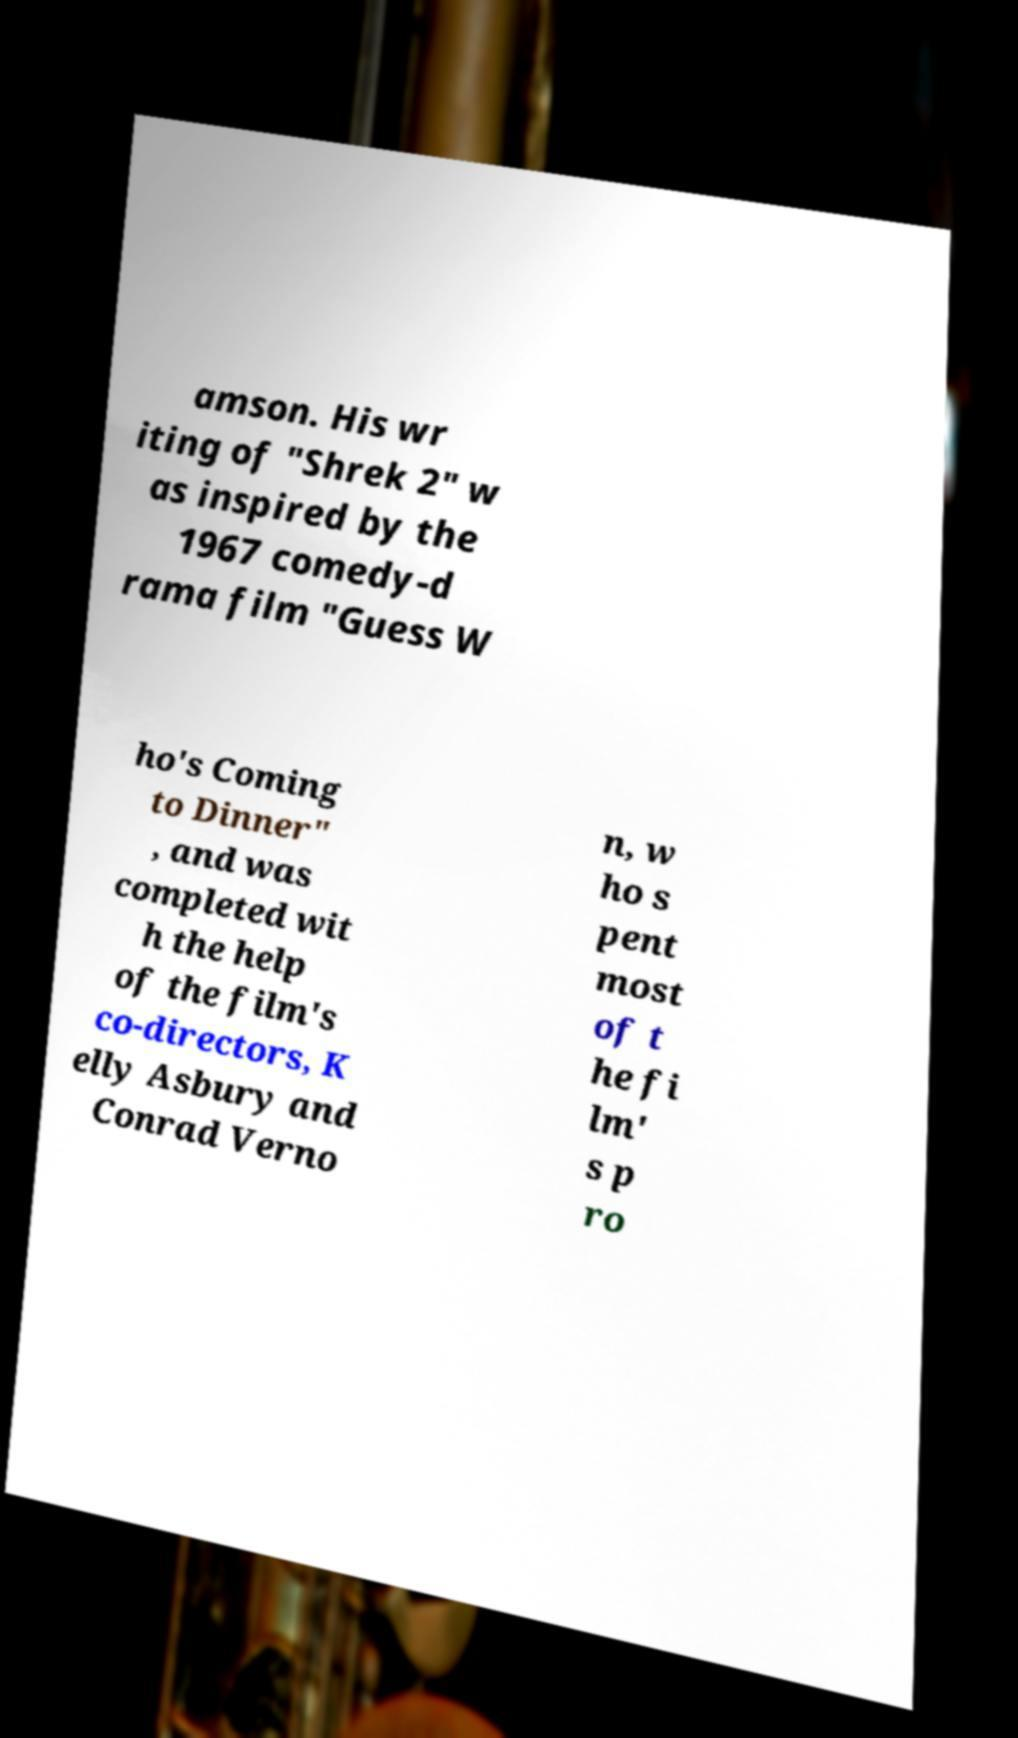Please identify and transcribe the text found in this image. amson. His wr iting of "Shrek 2" w as inspired by the 1967 comedy-d rama film "Guess W ho's Coming to Dinner" , and was completed wit h the help of the film's co-directors, K elly Asbury and Conrad Verno n, w ho s pent most of t he fi lm' s p ro 